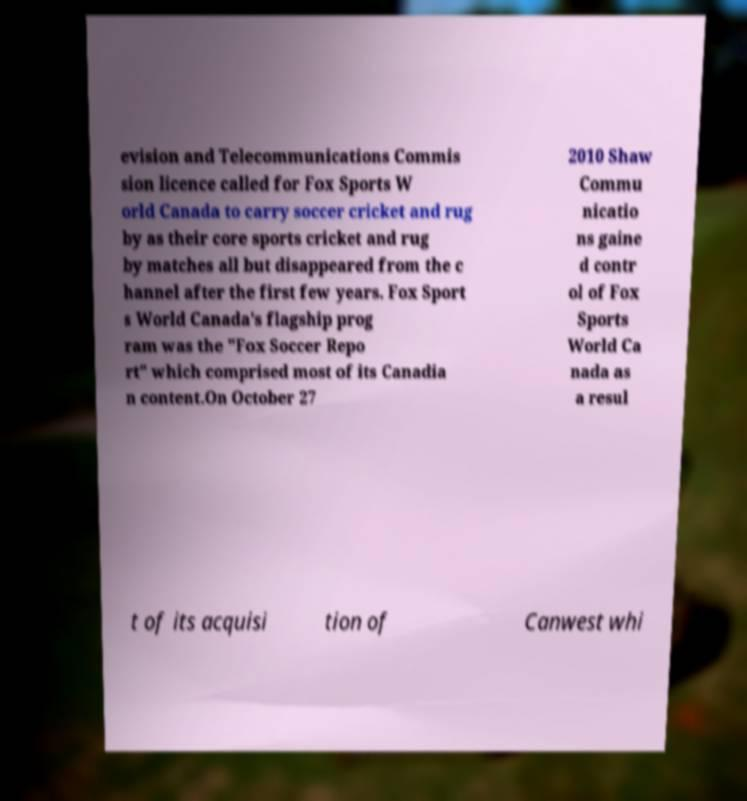I need the written content from this picture converted into text. Can you do that? evision and Telecommunications Commis sion licence called for Fox Sports W orld Canada to carry soccer cricket and rug by as their core sports cricket and rug by matches all but disappeared from the c hannel after the first few years. Fox Sport s World Canada's flagship prog ram was the "Fox Soccer Repo rt" which comprised most of its Canadia n content.On October 27 2010 Shaw Commu nicatio ns gaine d contr ol of Fox Sports World Ca nada as a resul t of its acquisi tion of Canwest whi 